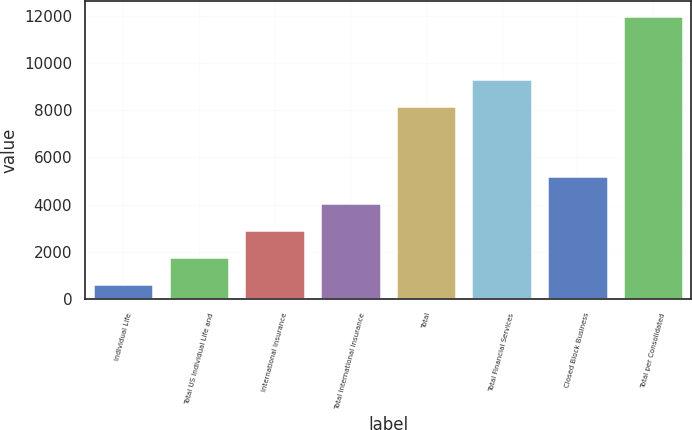<chart> <loc_0><loc_0><loc_500><loc_500><bar_chart><fcel>Individual Life<fcel>Total US Individual Life and<fcel>International Insurance<fcel>Total International Insurance<fcel>Total<fcel>Total Financial Services<fcel>Closed Block Business<fcel>Total per Consolidated<nl><fcel>656<fcel>1791.9<fcel>2927.8<fcel>4063.7<fcel>8200<fcel>9335.9<fcel>5199.6<fcel>12015<nl></chart> 